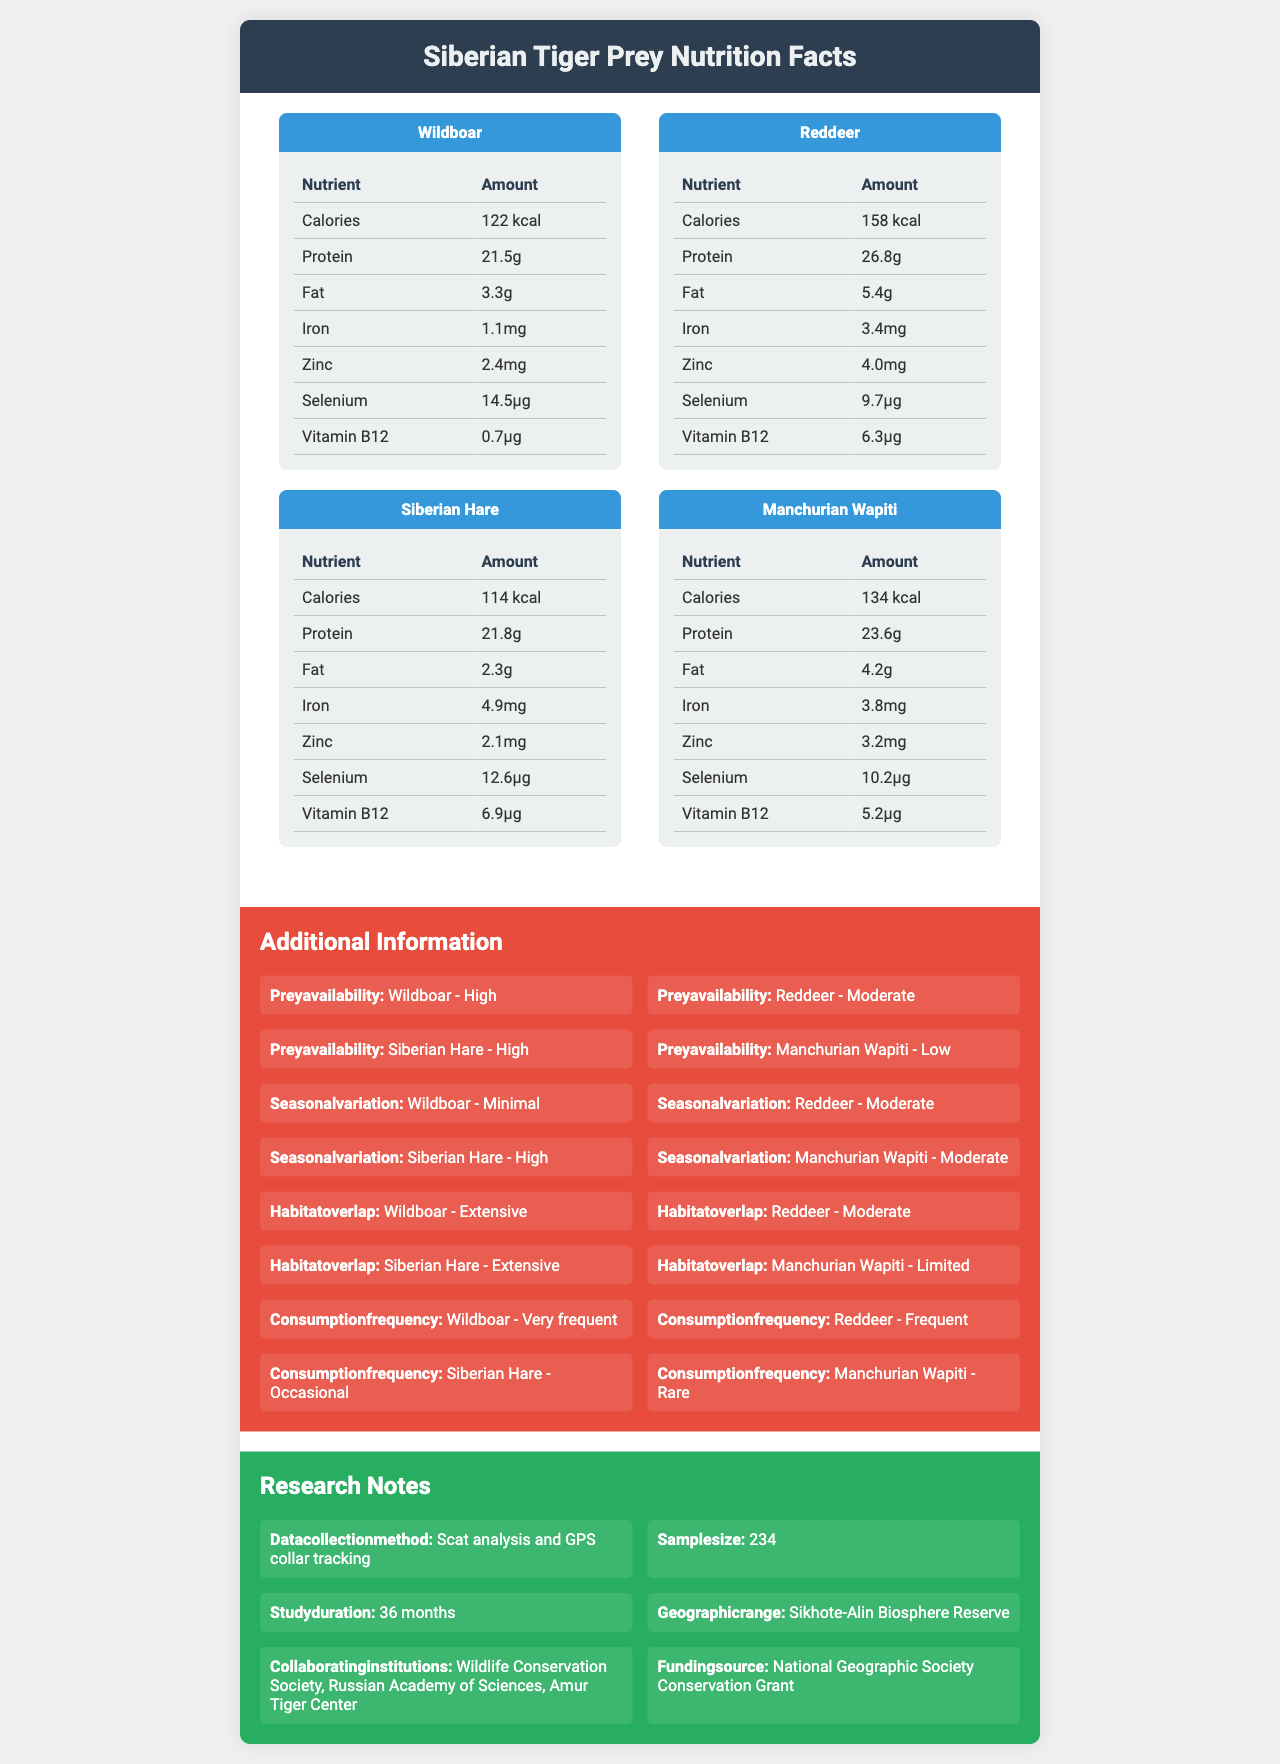what is the serving size for the prey species? The serving size for all prey species listed in the document is 100 grams.
Answer: 100g which prey species has the highest protein content per serving? The document shows that Red Deer has 26.8 grams of protein per serving, the highest among the listed prey species.
Answer: Red Deer what is the calorie content of a serving of Manchurian Wapiti? The calorie content per serving of Manchurian Wapiti is listed as 134 kcal.
Answer: 134 kcal which prey species has the most iron per serving? The Siberian Hare provides 4.9 mg of iron per serving, the highest among the listed prey.
Answer: Siberian Hare what is the habitat overlap for wild boar? The document mentions that wild boar has extensive habitat overlap.
Answer: Extensive which prey species has minimal seasonal variation? (choose one) 
A. Wild Boar
B. Red Deer
C. Siberian Hare
D. Manchurian Wapiti Wild Boar is listed as having minimal seasonal variation.
Answer: A which of the following nutrients is not present in any of the listed prey species?
I. Carbohydrates
II. Protein
III. Fat Carbohydrates are not present in any of the listed prey species, according to the document.
Answer: I is the fat content of Siberian Hare higher than that of Wild Boar? The fat content of Siberian Hare (2.3g) is lower than that of Wild Boar (3.3g).
Answer: No please summarize the main idea of the document. The main idea includes details on the nutritional content and additional contextual information related to the prey species of Siberian tigers, aiming to provide insights that support conservation efforts.
Answer: The document provides a comparative nutrient analysis of different prey species in the Siberian tiger's diet, including their macronutrients, micronutrients, fatty acids, and amino acids. Additionally, it offers information on prey availability, seasonal variation, habitat overlap, and research notes. what were the collaborating institutions involved in this study? According to the research notes, the collaborating institutions involved are the Wildlife Conservation Society, Russian Academy of Sciences, and Amur Tiger Center.
Answer: Wildlife Conservation Society, Russian Academy of Sciences, Amur Tiger Center does the document provide information on the specific methods used to collect dietary data? The document states that dietary data were collected using scat analysis and GPS collar tracking.
Answer: Yes when was the study duration? The research notes indicate that the study duration lasted 36 months.
Answer: 36 months how does the frequency of Manchurian Wapiti in the diet compare to that of Red Deer? The document mentions that Manchurian Wapiti is rarely consumed while Red Deer is frequently consumed.
Answer: Rare vs Frequent can I determine the exact funding amount for the study? The document states the study was funded by the National Geographic Society Conservation Grant but does not provide the exact amount.
Answer: Cannot be determined 